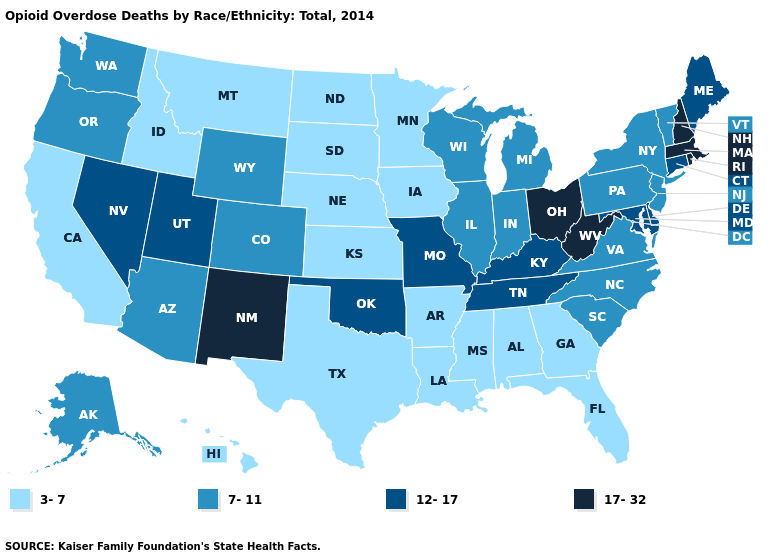What is the highest value in the Northeast ?
Quick response, please. 17-32. What is the highest value in states that border Tennessee?
Quick response, please. 12-17. What is the value of Pennsylvania?
Quick response, please. 7-11. Name the states that have a value in the range 7-11?
Give a very brief answer. Alaska, Arizona, Colorado, Illinois, Indiana, Michigan, New Jersey, New York, North Carolina, Oregon, Pennsylvania, South Carolina, Vermont, Virginia, Washington, Wisconsin, Wyoming. Is the legend a continuous bar?
Short answer required. No. What is the lowest value in the USA?
Quick response, please. 3-7. Name the states that have a value in the range 3-7?
Keep it brief. Alabama, Arkansas, California, Florida, Georgia, Hawaii, Idaho, Iowa, Kansas, Louisiana, Minnesota, Mississippi, Montana, Nebraska, North Dakota, South Dakota, Texas. Among the states that border Maryland , does West Virginia have the highest value?
Give a very brief answer. Yes. Which states have the highest value in the USA?
Concise answer only. Massachusetts, New Hampshire, New Mexico, Ohio, Rhode Island, West Virginia. What is the value of Louisiana?
Give a very brief answer. 3-7. What is the value of Delaware?
Keep it brief. 12-17. Name the states that have a value in the range 7-11?
Be succinct. Alaska, Arizona, Colorado, Illinois, Indiana, Michigan, New Jersey, New York, North Carolina, Oregon, Pennsylvania, South Carolina, Vermont, Virginia, Washington, Wisconsin, Wyoming. Does Florida have a higher value than North Carolina?
Write a very short answer. No. Name the states that have a value in the range 12-17?
Write a very short answer. Connecticut, Delaware, Kentucky, Maine, Maryland, Missouri, Nevada, Oklahoma, Tennessee, Utah. 